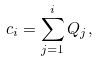Convert formula to latex. <formula><loc_0><loc_0><loc_500><loc_500>c _ { i } = \sum _ { j = 1 } ^ { i } Q _ { j } ,</formula> 